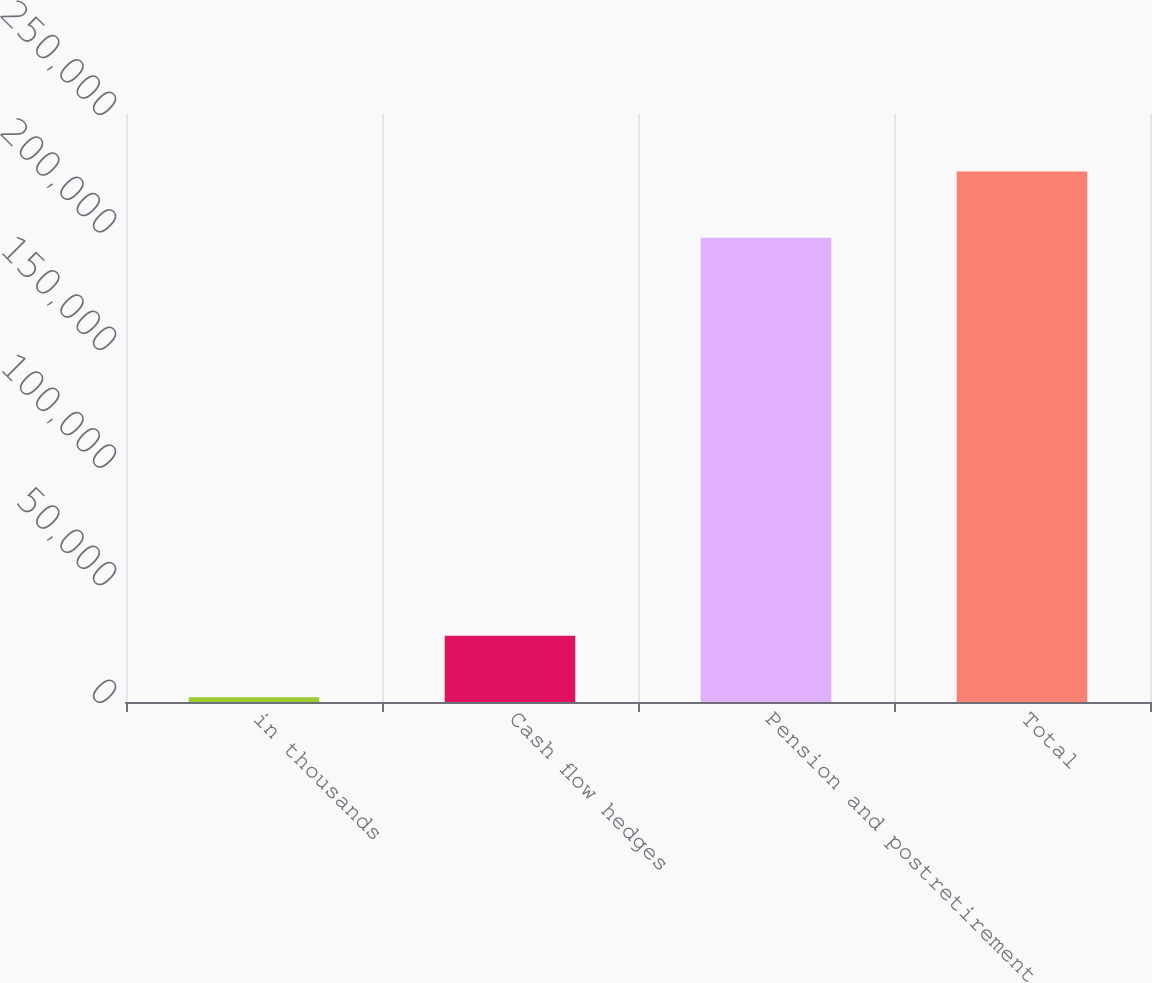<chart> <loc_0><loc_0><loc_500><loc_500><bar_chart><fcel>in thousands<fcel>Cash flow hedges<fcel>Pension and postretirement<fcel>Total<nl><fcel>2012<fcel>28170<fcel>197347<fcel>225517<nl></chart> 